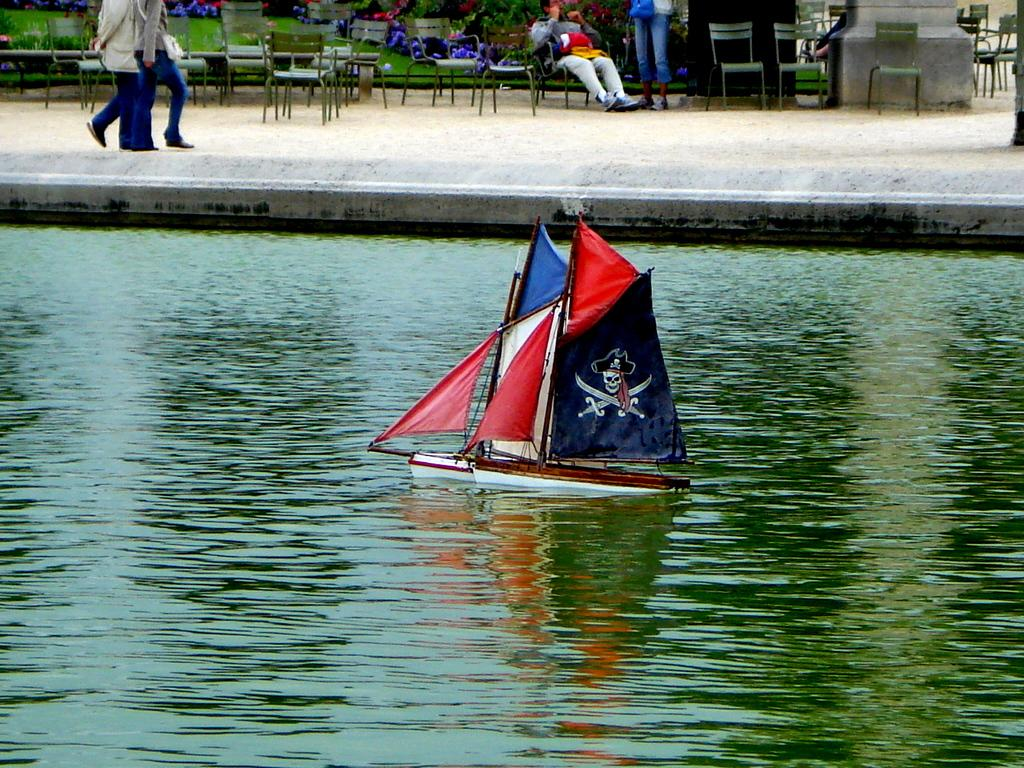What is the main element in the image? There is water in the image. What is on the water in the image? There are boats on the water. What can be seen in the background of the image? There are people and a person sitting in the background. What type of furniture is present in the background? There are chairs in the background. What type of ink is being used by the person sitting in the background? There is no indication in the image that the person sitting in the background is using ink or any writing instrument. 